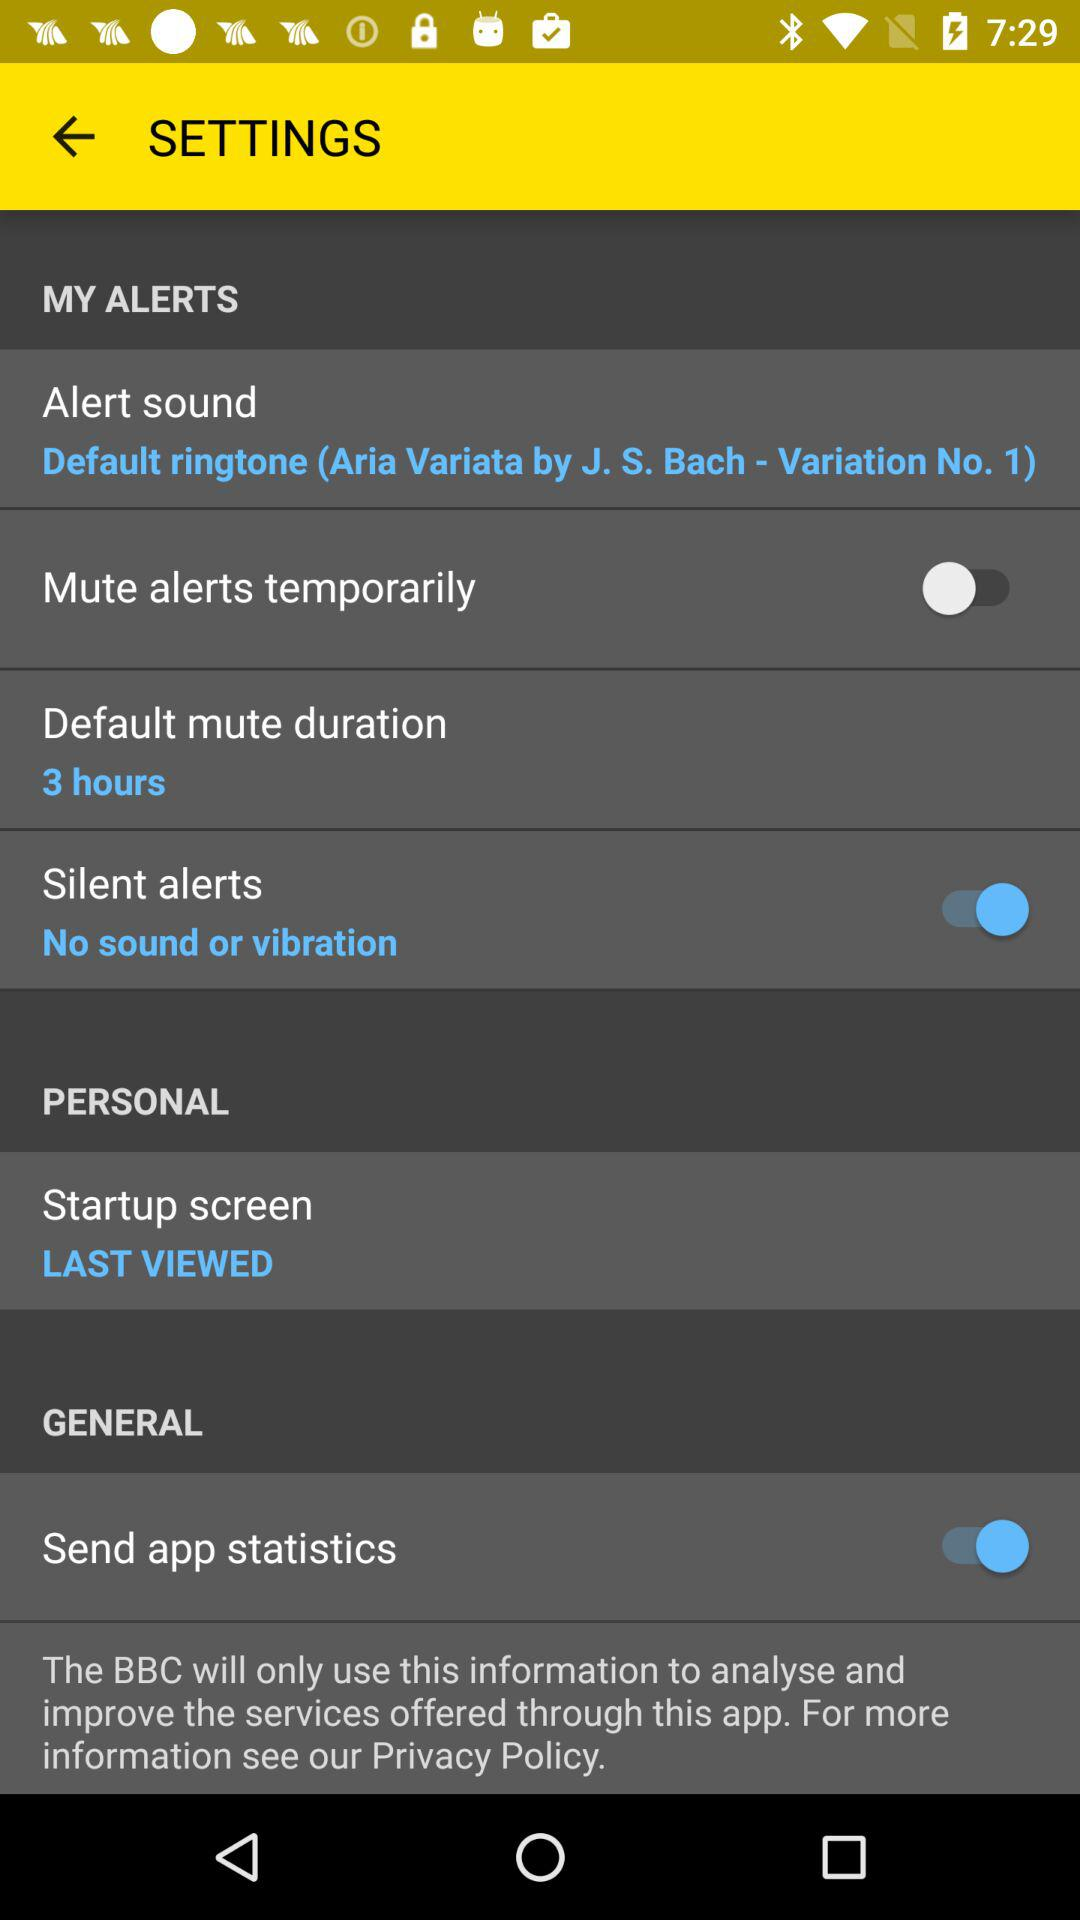What is the status of "Silent alerts"? The status of "Silent alerts" is "on". 